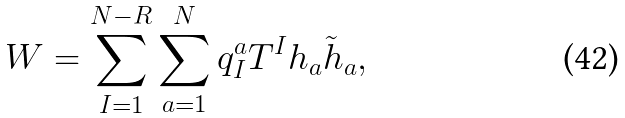<formula> <loc_0><loc_0><loc_500><loc_500>W = \sum _ { I = 1 } ^ { N - R } \sum _ { a = 1 } ^ { N } q _ { I } ^ { a } T ^ { I } h _ { a } \tilde { h } _ { a } ,</formula> 